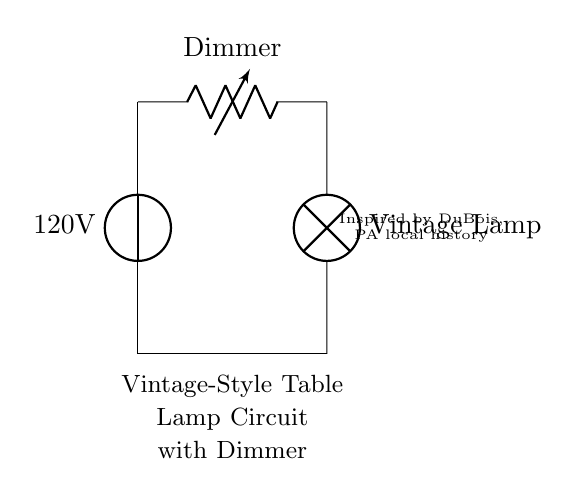What is the voltage of this circuit? The circuit has a voltage source marked as 120 volts, which is the electrical potential difference supplied to the circuit.
Answer: 120 volts What component is represented as a variable resistor in this circuit? The variable resistor in this circuit is labeled as a Dimmer, which allows for adjusting the brightness of the lamp by varying the resistance.
Answer: Dimmer How many main components are there in this circuit? There are three main components in the circuit: the voltage source, the dimmer switch, and the vintage lamp.
Answer: Three What type of lamp is used in this circuit? The circuit diagram specifies that a Vintage Lamp is used, which is a distinct type of lamp known for its aesthetic characteristic reminiscent of older designs.
Answer: Vintage Lamp What is the purpose of the dimmer in the circuit? The dimmer's purpose is to adjust the brightness of the lamp by regulating the current flowing to it, thus changing its intensity without turning it off completely.
Answer: Adjust brightness What would happen if the dimmer is set to zero resistance? If the dimmer is set to zero resistance, it would allow maximum current to flow to the vintage lamp, resulting in the lamp being at its brightest or potentially causing it to burn out due to excessive current.
Answer: Maximum brightness 